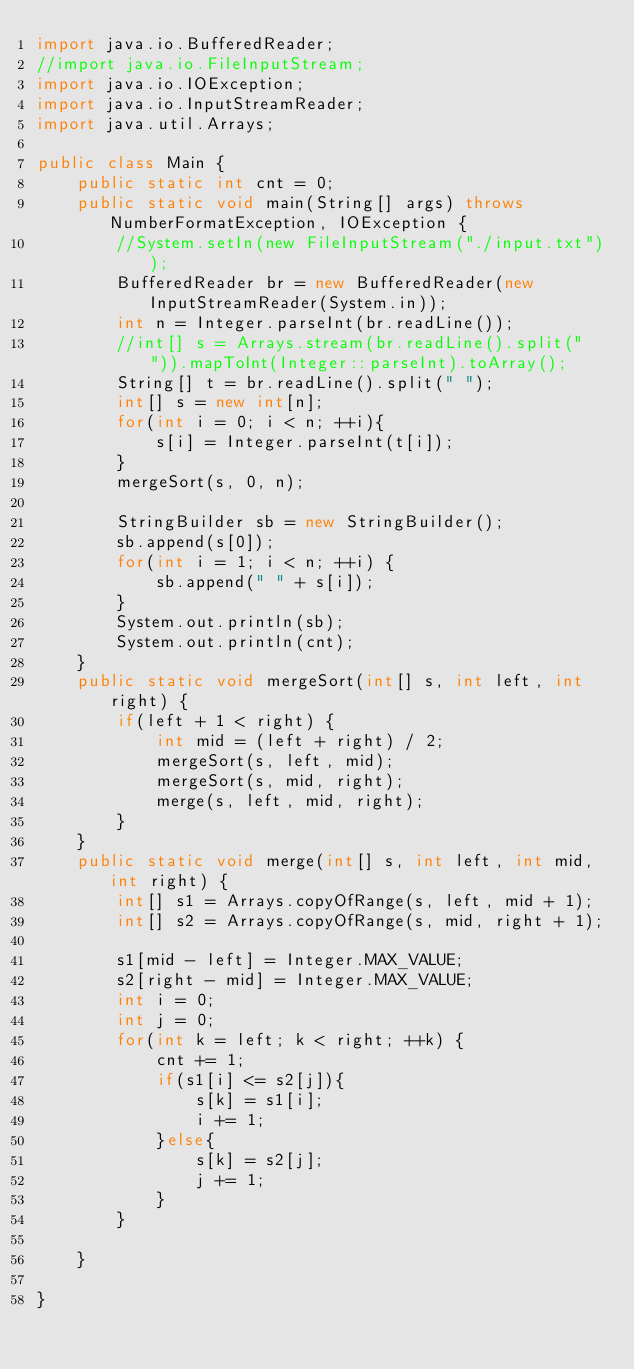<code> <loc_0><loc_0><loc_500><loc_500><_Java_>import java.io.BufferedReader;
//import java.io.FileInputStream;
import java.io.IOException;
import java.io.InputStreamReader;
import java.util.Arrays;

public class Main {
	public static int cnt = 0;
	public static void main(String[] args) throws NumberFormatException, IOException {
		//System.setIn(new FileInputStream("./input.txt"));
		BufferedReader br = new BufferedReader(new InputStreamReader(System.in));
		int n = Integer.parseInt(br.readLine());
		//int[] s = Arrays.stream(br.readLine().split(" ")).mapToInt(Integer::parseInt).toArray();
		String[] t = br.readLine().split(" ");
		int[] s = new int[n];
		for(int i = 0; i < n; ++i){
			s[i] = Integer.parseInt(t[i]);
		}
		mergeSort(s, 0, n);
		
		StringBuilder sb = new StringBuilder();
		sb.append(s[0]);
		for(int i = 1; i < n; ++i) {
			sb.append(" " + s[i]);
		}
		System.out.println(sb);
		System.out.println(cnt);
	}
	public static void mergeSort(int[] s, int left, int right) {
		if(left + 1 < right) {
			int mid = (left + right) / 2;
			mergeSort(s, left, mid);
			mergeSort(s, mid, right);
			merge(s, left, mid, right);
		}
	}
	public static void merge(int[] s, int left, int mid, int right) {
		int[] s1 = Arrays.copyOfRange(s, left, mid + 1);
		int[] s2 = Arrays.copyOfRange(s, mid, right + 1);
		
		s1[mid - left] = Integer.MAX_VALUE;
		s2[right - mid] = Integer.MAX_VALUE;
		int i = 0;
		int j = 0;
		for(int k = left; k < right; ++k) {
			cnt += 1;
			if(s1[i] <= s2[j]){
				s[k] = s1[i];
				i += 1;
			}else{
				s[k] = s2[j];
				j += 1;
			}
		}
		
	}
	
}</code> 